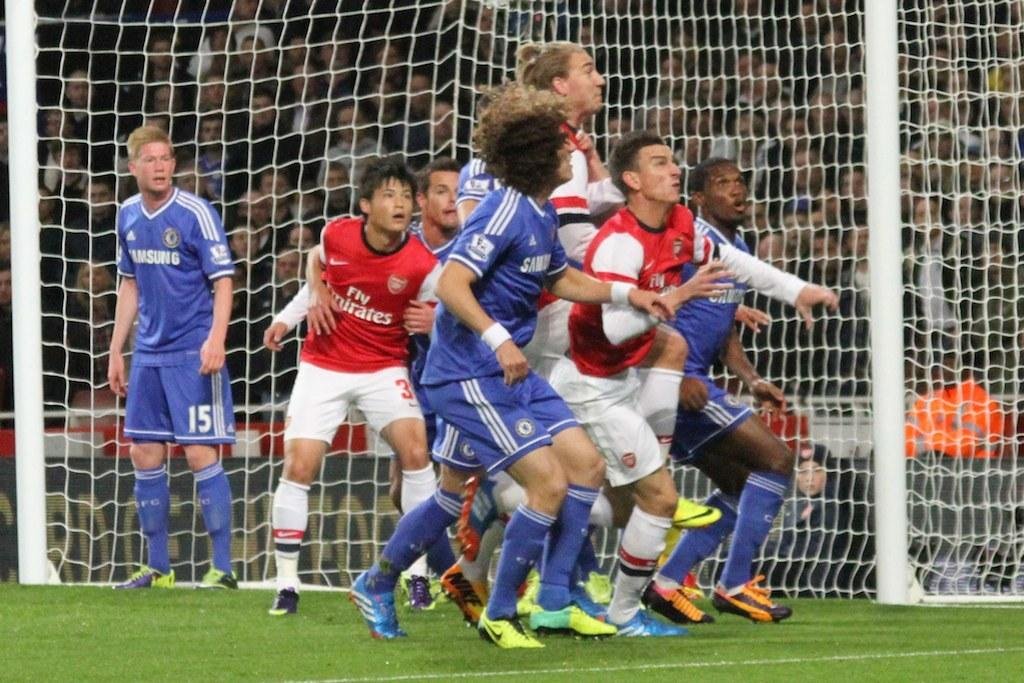<image>
Share a concise interpretation of the image provided. The team in blue wearing Samsung jersey's are playing against the team in red 